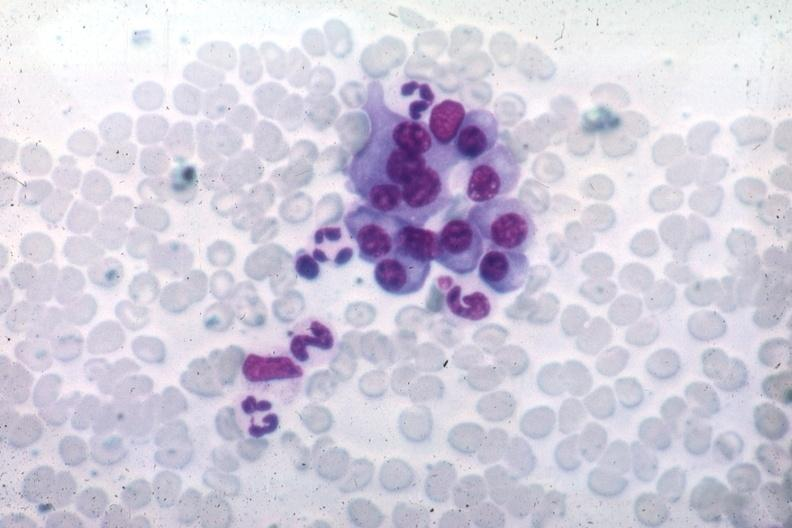what differentiated plasma cells source unknown?
Answer the question using a single word or phrase. This image shows wrights typical 